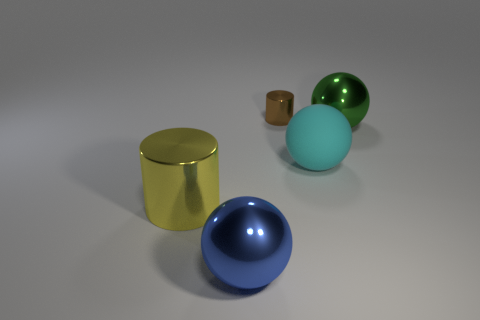What color is the rubber thing? The sphere in the image appears to be a shade of light blue, commonly referred to as cyan, which is typically associated with rubber balls used in various games and activities. Its texture also seems to echo the characteristic matte finish of a rubber surface. 